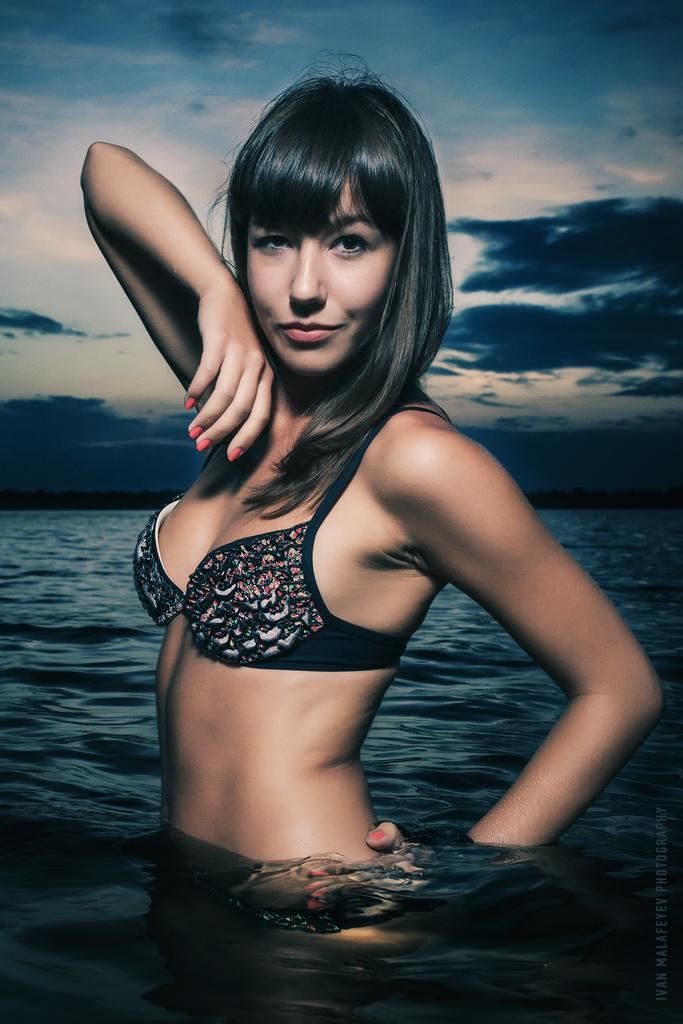What is the main subject of the image? There is a lady in the water in the center of the image. What can be seen in the background of the image? There are clouds in the sky in the background. Is there any text present in the image? Yes, there is some text at the bottom of the image. Can you see the lady's dad in the image? There is no mention of a dad or any other person in the image besides the lady in the water. 